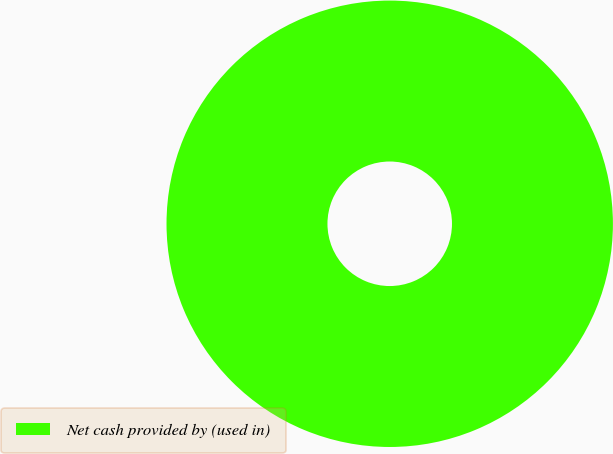<chart> <loc_0><loc_0><loc_500><loc_500><pie_chart><fcel>Net cash provided by (used in)<nl><fcel>100.0%<nl></chart> 